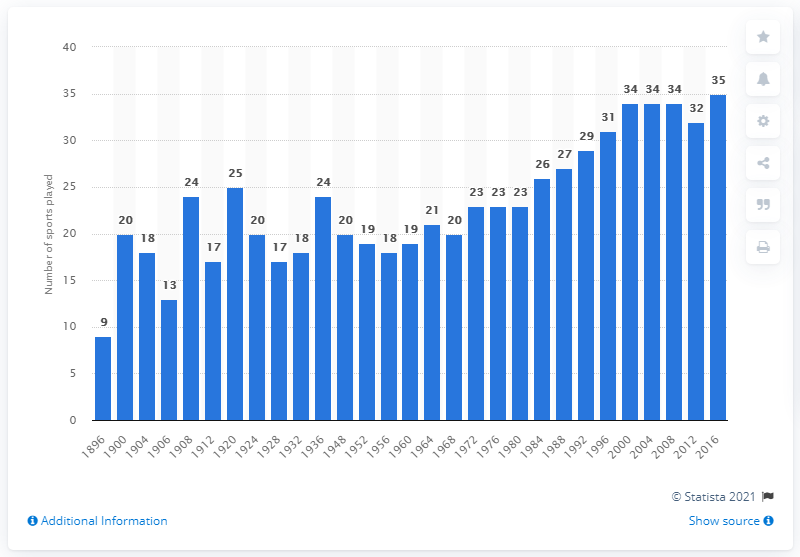Outline some significant characteristics in this image. In the year 1900, 20 sporting events took place at the Summer Olympic Games. During the period between 1896 and 2016, a total of 20 Summer Olympic Games were held, during which a large number of sporting events took place. 